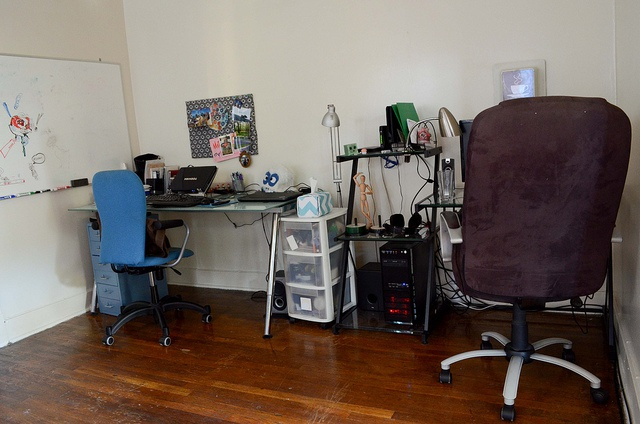Describe the objects in this image and their specific colors. I can see chair in darkgray, black, and gray tones, chair in darkgray, blue, black, and gray tones, laptop in darkgray, black, and gray tones, keyboard in darkgray, black, and gray tones, and book in black, darkgreen, and darkgray tones in this image. 